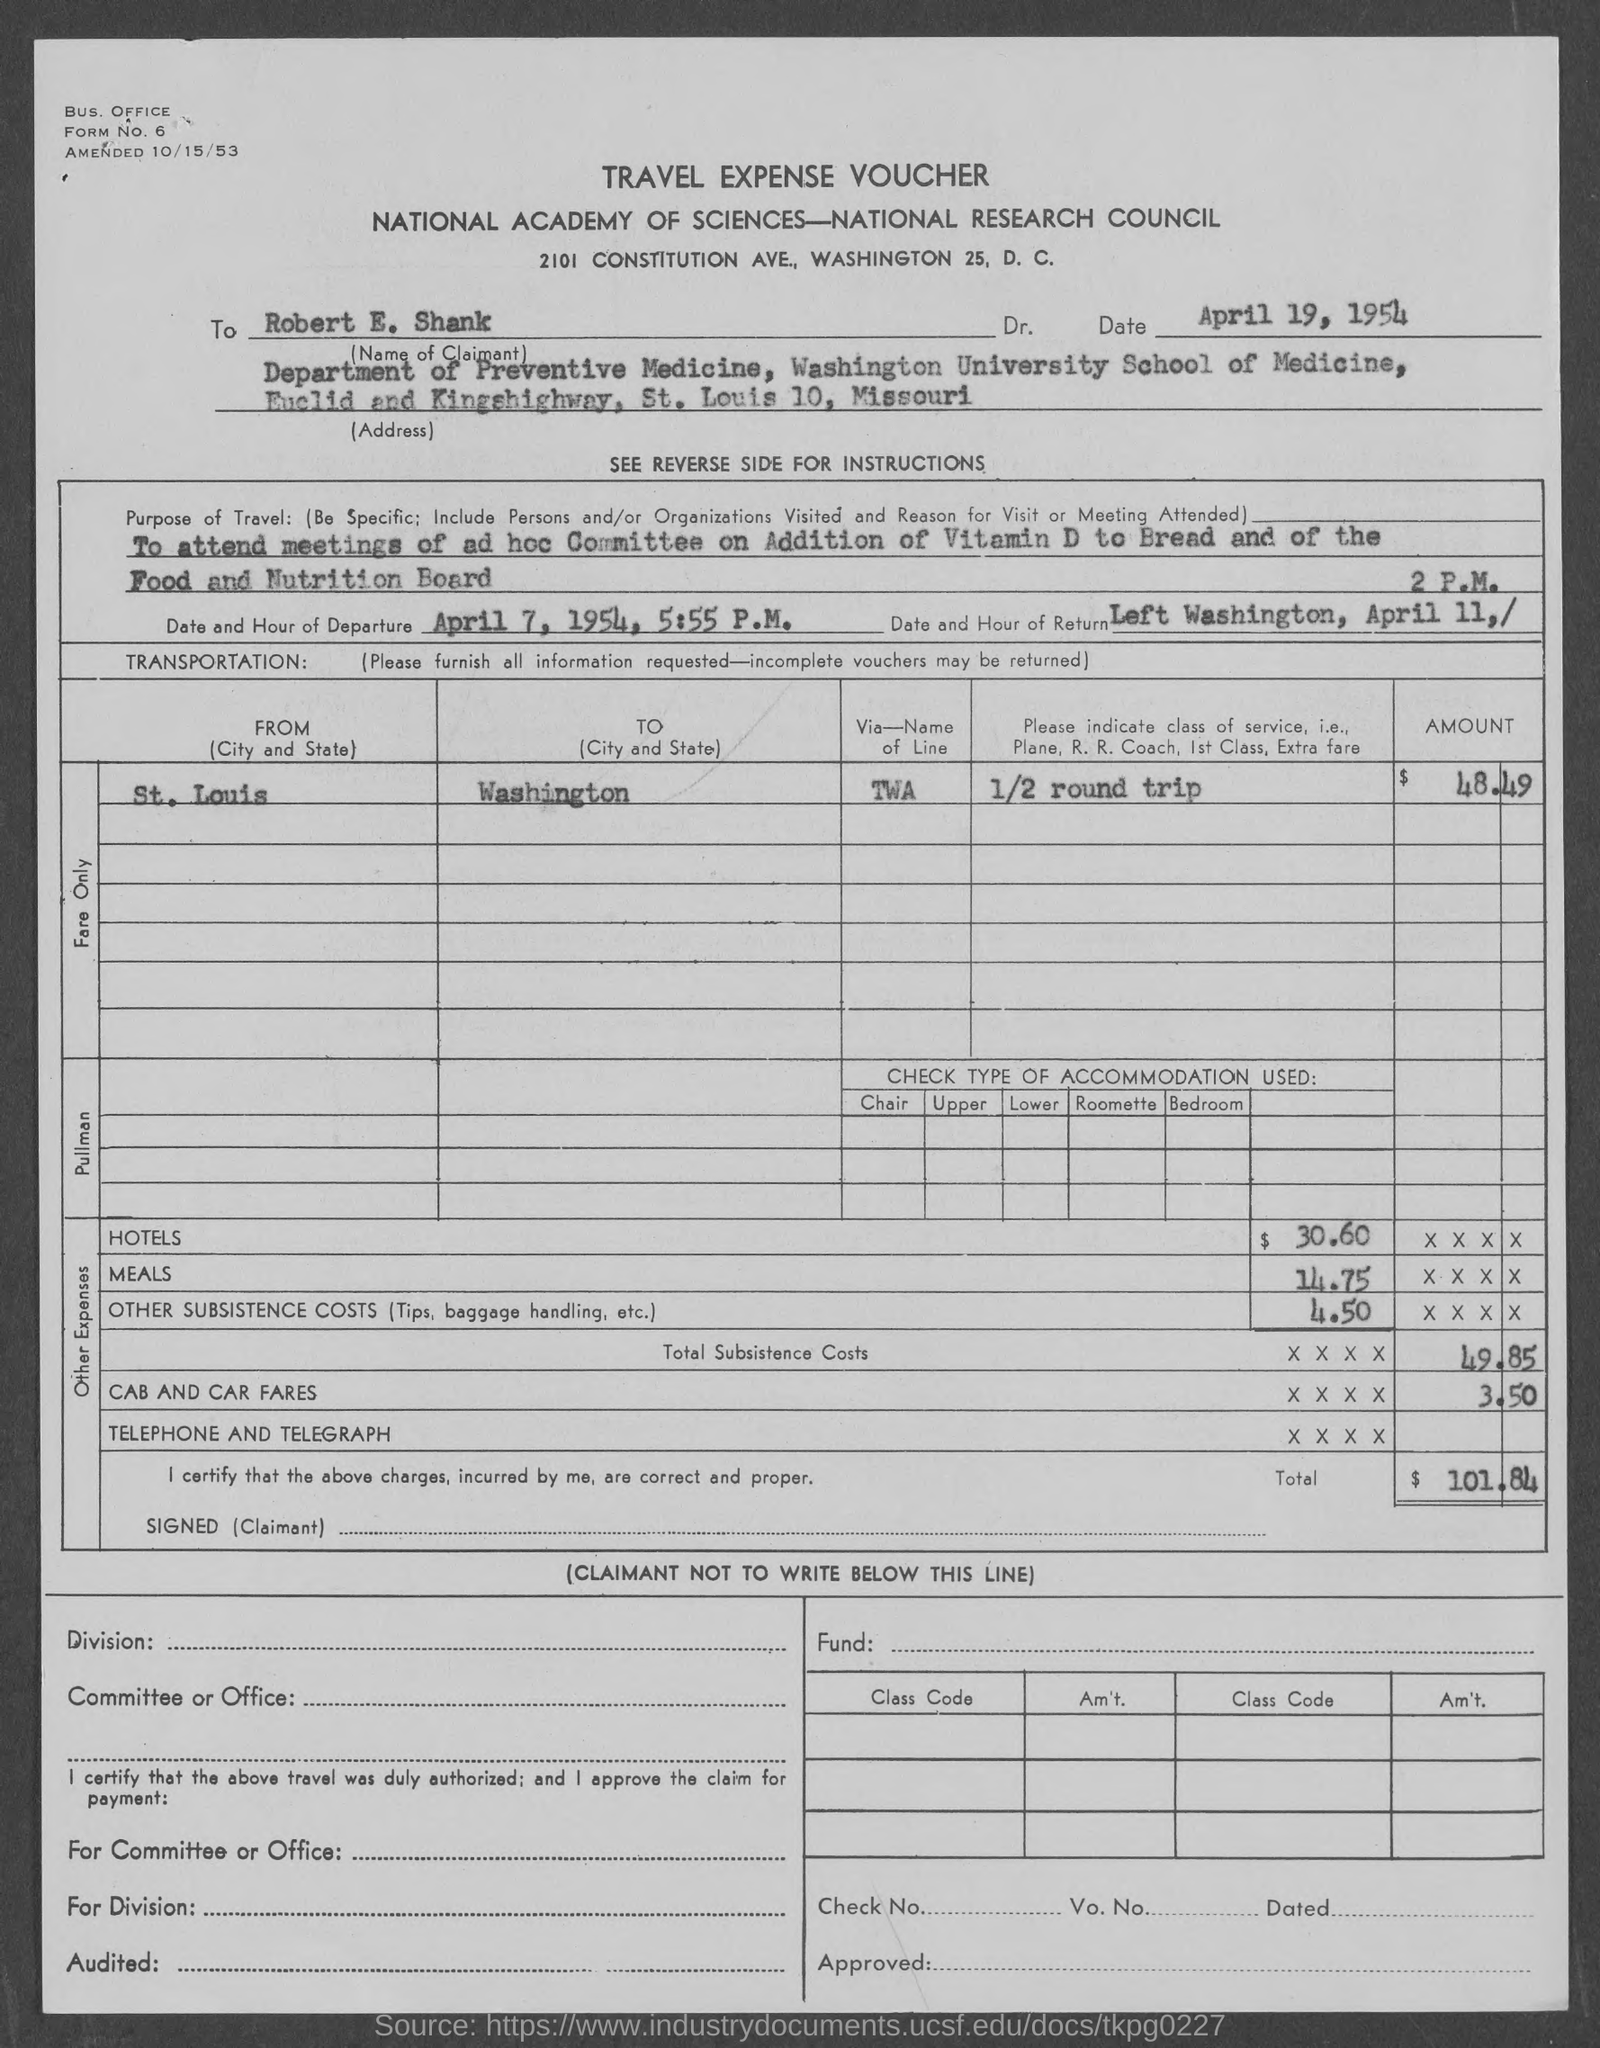What is this voucher on?
Give a very brief answer. TRAVEL EXPENSE VOUCHER. Where was the travel to?
Your answer should be compact. Washington. 